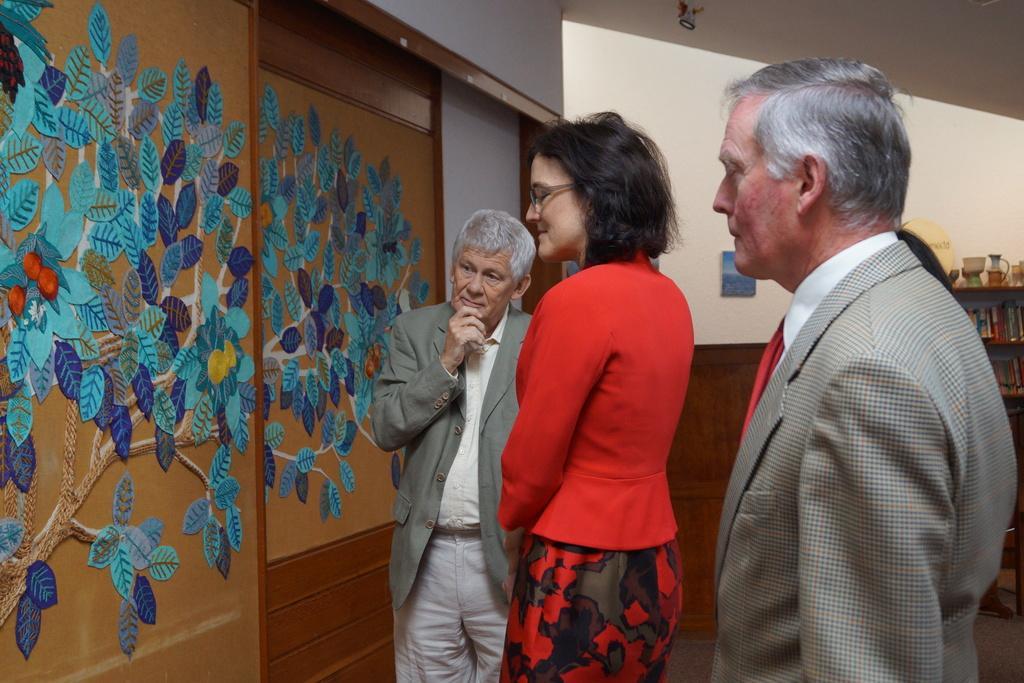Could you give a brief overview of what you see in this image? In this picture we can see some people are standing in front of the wall and looking painting which is drawn on the wall. 